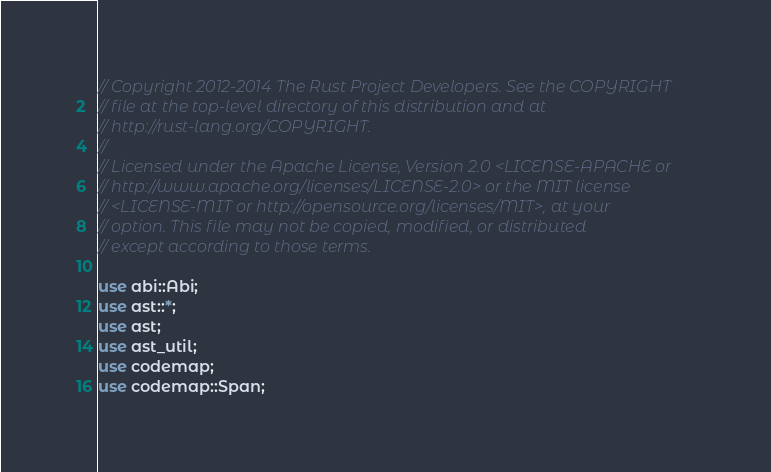<code> <loc_0><loc_0><loc_500><loc_500><_Rust_>// Copyright 2012-2014 The Rust Project Developers. See the COPYRIGHT
// file at the top-level directory of this distribution and at
// http://rust-lang.org/COPYRIGHT.
//
// Licensed under the Apache License, Version 2.0 <LICENSE-APACHE or
// http://www.apache.org/licenses/LICENSE-2.0> or the MIT license
// <LICENSE-MIT or http://opensource.org/licenses/MIT>, at your
// option. This file may not be copied, modified, or distributed
// except according to those terms.

use abi::Abi;
use ast::*;
use ast;
use ast_util;
use codemap;
use codemap::Span;</code> 